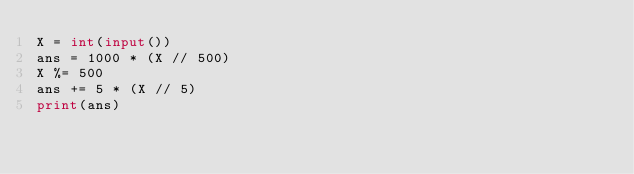<code> <loc_0><loc_0><loc_500><loc_500><_Python_>X = int(input())
ans = 1000 * (X // 500)
X %= 500
ans += 5 * (X // 5)
print(ans)</code> 